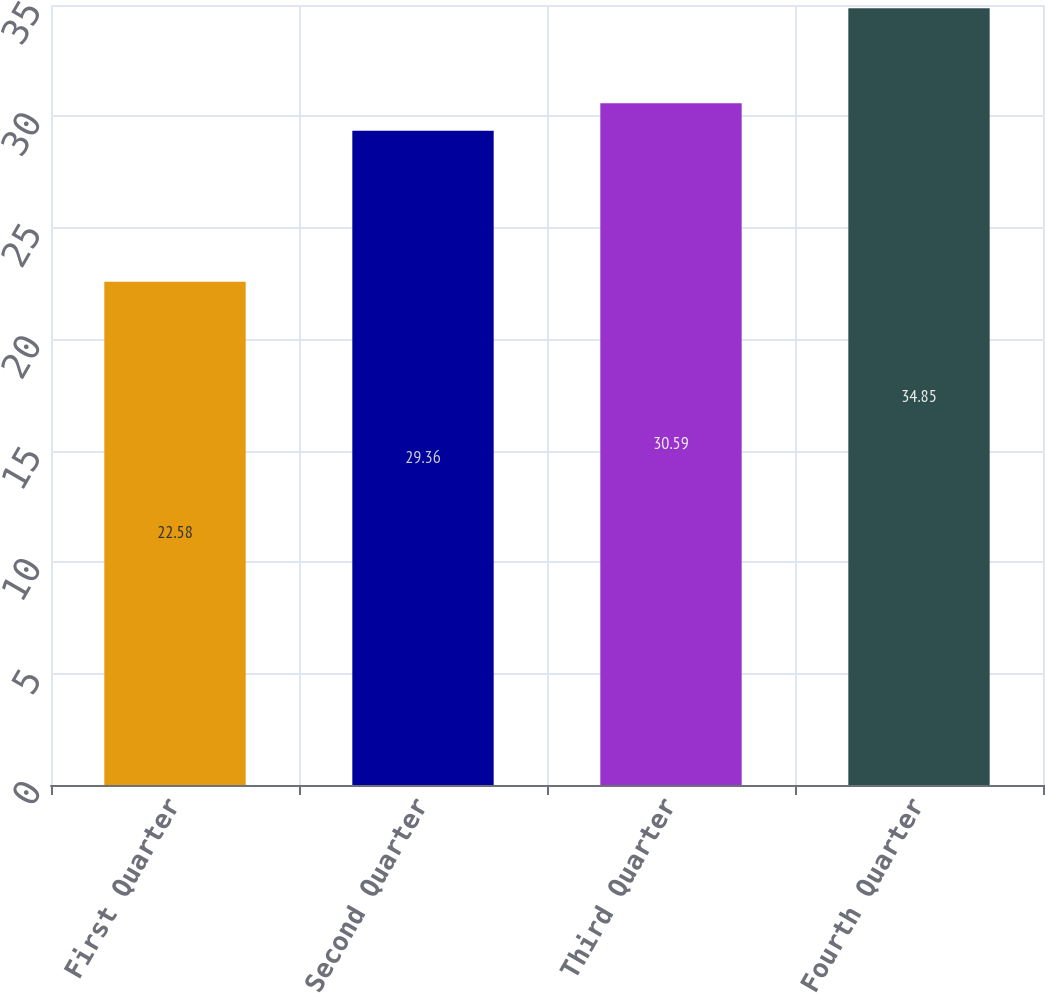<chart> <loc_0><loc_0><loc_500><loc_500><bar_chart><fcel>First Quarter<fcel>Second Quarter<fcel>Third Quarter<fcel>Fourth Quarter<nl><fcel>22.58<fcel>29.36<fcel>30.59<fcel>34.85<nl></chart> 